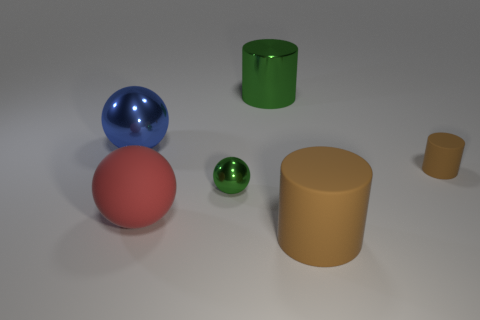Do the small sphere and the cylinder on the left side of the big brown rubber cylinder have the same color? Yes, the small sphere and the cylinder to the left of the large brown cylinder appear to have a similar shade of green under the current lighting conditions, which could be described as a vivid or rich green. 